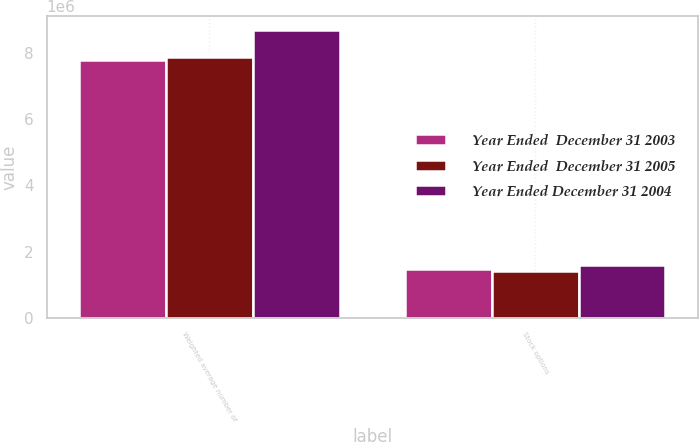Convert chart. <chart><loc_0><loc_0><loc_500><loc_500><stacked_bar_chart><ecel><fcel>Weighted average number of<fcel>Stock options<nl><fcel>Year Ended  December 31 2003<fcel>7.78438e+06<fcel>1.46353e+06<nl><fcel>Year Ended  December 31 2005<fcel>7.87687e+06<fcel>1.40426e+06<nl><fcel>Year Ended December 31 2004<fcel>8.67436e+06<fcel>1.59284e+06<nl></chart> 